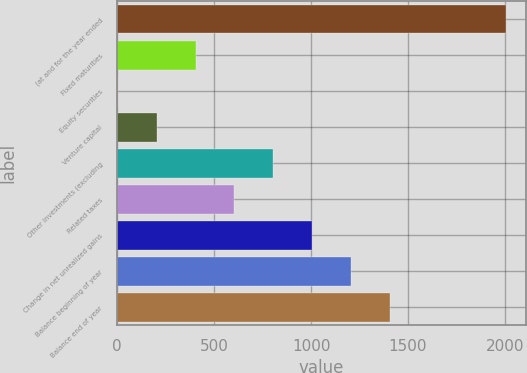<chart> <loc_0><loc_0><loc_500><loc_500><bar_chart><fcel>(at and for the year ended<fcel>Fixed maturities<fcel>Equity securities<fcel>Venture capital<fcel>Other investments (excluding<fcel>Related taxes<fcel>Change in net unrealized gains<fcel>Balance beginning of year<fcel>Balance end of year<nl><fcel>2006<fcel>404.4<fcel>4<fcel>204.2<fcel>804.8<fcel>604.6<fcel>1005<fcel>1205.2<fcel>1405.4<nl></chart> 